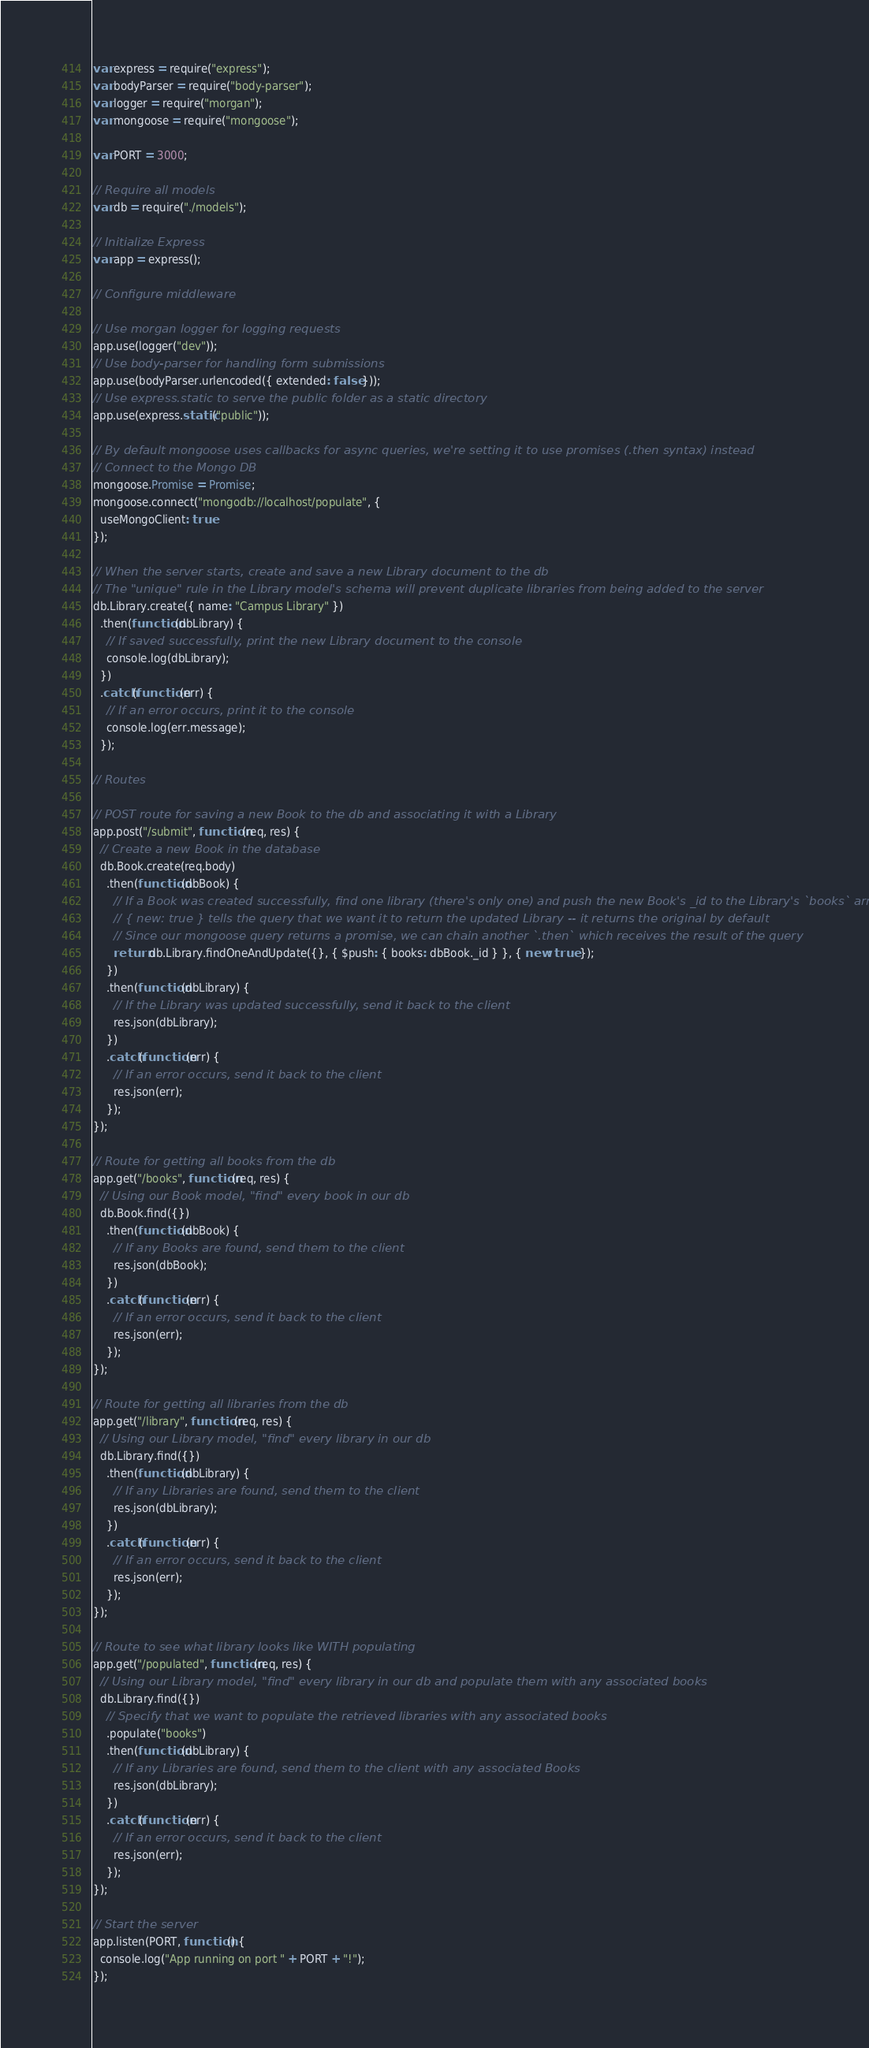<code> <loc_0><loc_0><loc_500><loc_500><_JavaScript_>var express = require("express");
var bodyParser = require("body-parser");
var logger = require("morgan");
var mongoose = require("mongoose");

var PORT = 3000;

// Require all models
var db = require("./models");

// Initialize Express
var app = express();

// Configure middleware

// Use morgan logger for logging requests
app.use(logger("dev"));
// Use body-parser for handling form submissions
app.use(bodyParser.urlencoded({ extended: false }));
// Use express.static to serve the public folder as a static directory
app.use(express.static("public"));

// By default mongoose uses callbacks for async queries, we're setting it to use promises (.then syntax) instead
// Connect to the Mongo DB
mongoose.Promise = Promise;
mongoose.connect("mongodb://localhost/populate", {
  useMongoClient: true
});

// When the server starts, create and save a new Library document to the db
// The "unique" rule in the Library model's schema will prevent duplicate libraries from being added to the server
db.Library.create({ name: "Campus Library" })
  .then(function(dbLibrary) {
    // If saved successfully, print the new Library document to the console
    console.log(dbLibrary);
  })
  .catch(function(err) {
    // If an error occurs, print it to the console
    console.log(err.message);
  });

// Routes

// POST route for saving a new Book to the db and associating it with a Library
app.post("/submit", function(req, res) {
  // Create a new Book in the database
  db.Book.create(req.body)
    .then(function(dbBook) {
      // If a Book was created successfully, find one library (there's only one) and push the new Book's _id to the Library's `books` array
      // { new: true } tells the query that we want it to return the updated Library -- it returns the original by default
      // Since our mongoose query returns a promise, we can chain another `.then` which receives the result of the query
      return db.Library.findOneAndUpdate({}, { $push: { books: dbBook._id } }, { new: true });
    })
    .then(function(dbLibrary) {
      // If the Library was updated successfully, send it back to the client
      res.json(dbLibrary);
    })
    .catch(function(err) {
      // If an error occurs, send it back to the client
      res.json(err);
    });
});

// Route for getting all books from the db
app.get("/books", function(req, res) {
  // Using our Book model, "find" every book in our db
  db.Book.find({})
    .then(function(dbBook) {
      // If any Books are found, send them to the client
      res.json(dbBook);
    })
    .catch(function(err) {
      // If an error occurs, send it back to the client
      res.json(err);
    });
});

// Route for getting all libraries from the db
app.get("/library", function(req, res) {
  // Using our Library model, "find" every library in our db
  db.Library.find({})
    .then(function(dbLibrary) {
      // If any Libraries are found, send them to the client
      res.json(dbLibrary);
    })
    .catch(function(err) {
      // If an error occurs, send it back to the client
      res.json(err);
    });
});

// Route to see what library looks like WITH populating
app.get("/populated", function(req, res) {
  // Using our Library model, "find" every library in our db and populate them with any associated books
  db.Library.find({})
    // Specify that we want to populate the retrieved libraries with any associated books
    .populate("books")
    .then(function(dbLibrary) {
      // If any Libraries are found, send them to the client with any associated Books
      res.json(dbLibrary);
    })
    .catch(function(err) {
      // If an error occurs, send it back to the client
      res.json(err);
    });
});

// Start the server
app.listen(PORT, function() {
  console.log("App running on port " + PORT + "!");
});
</code> 